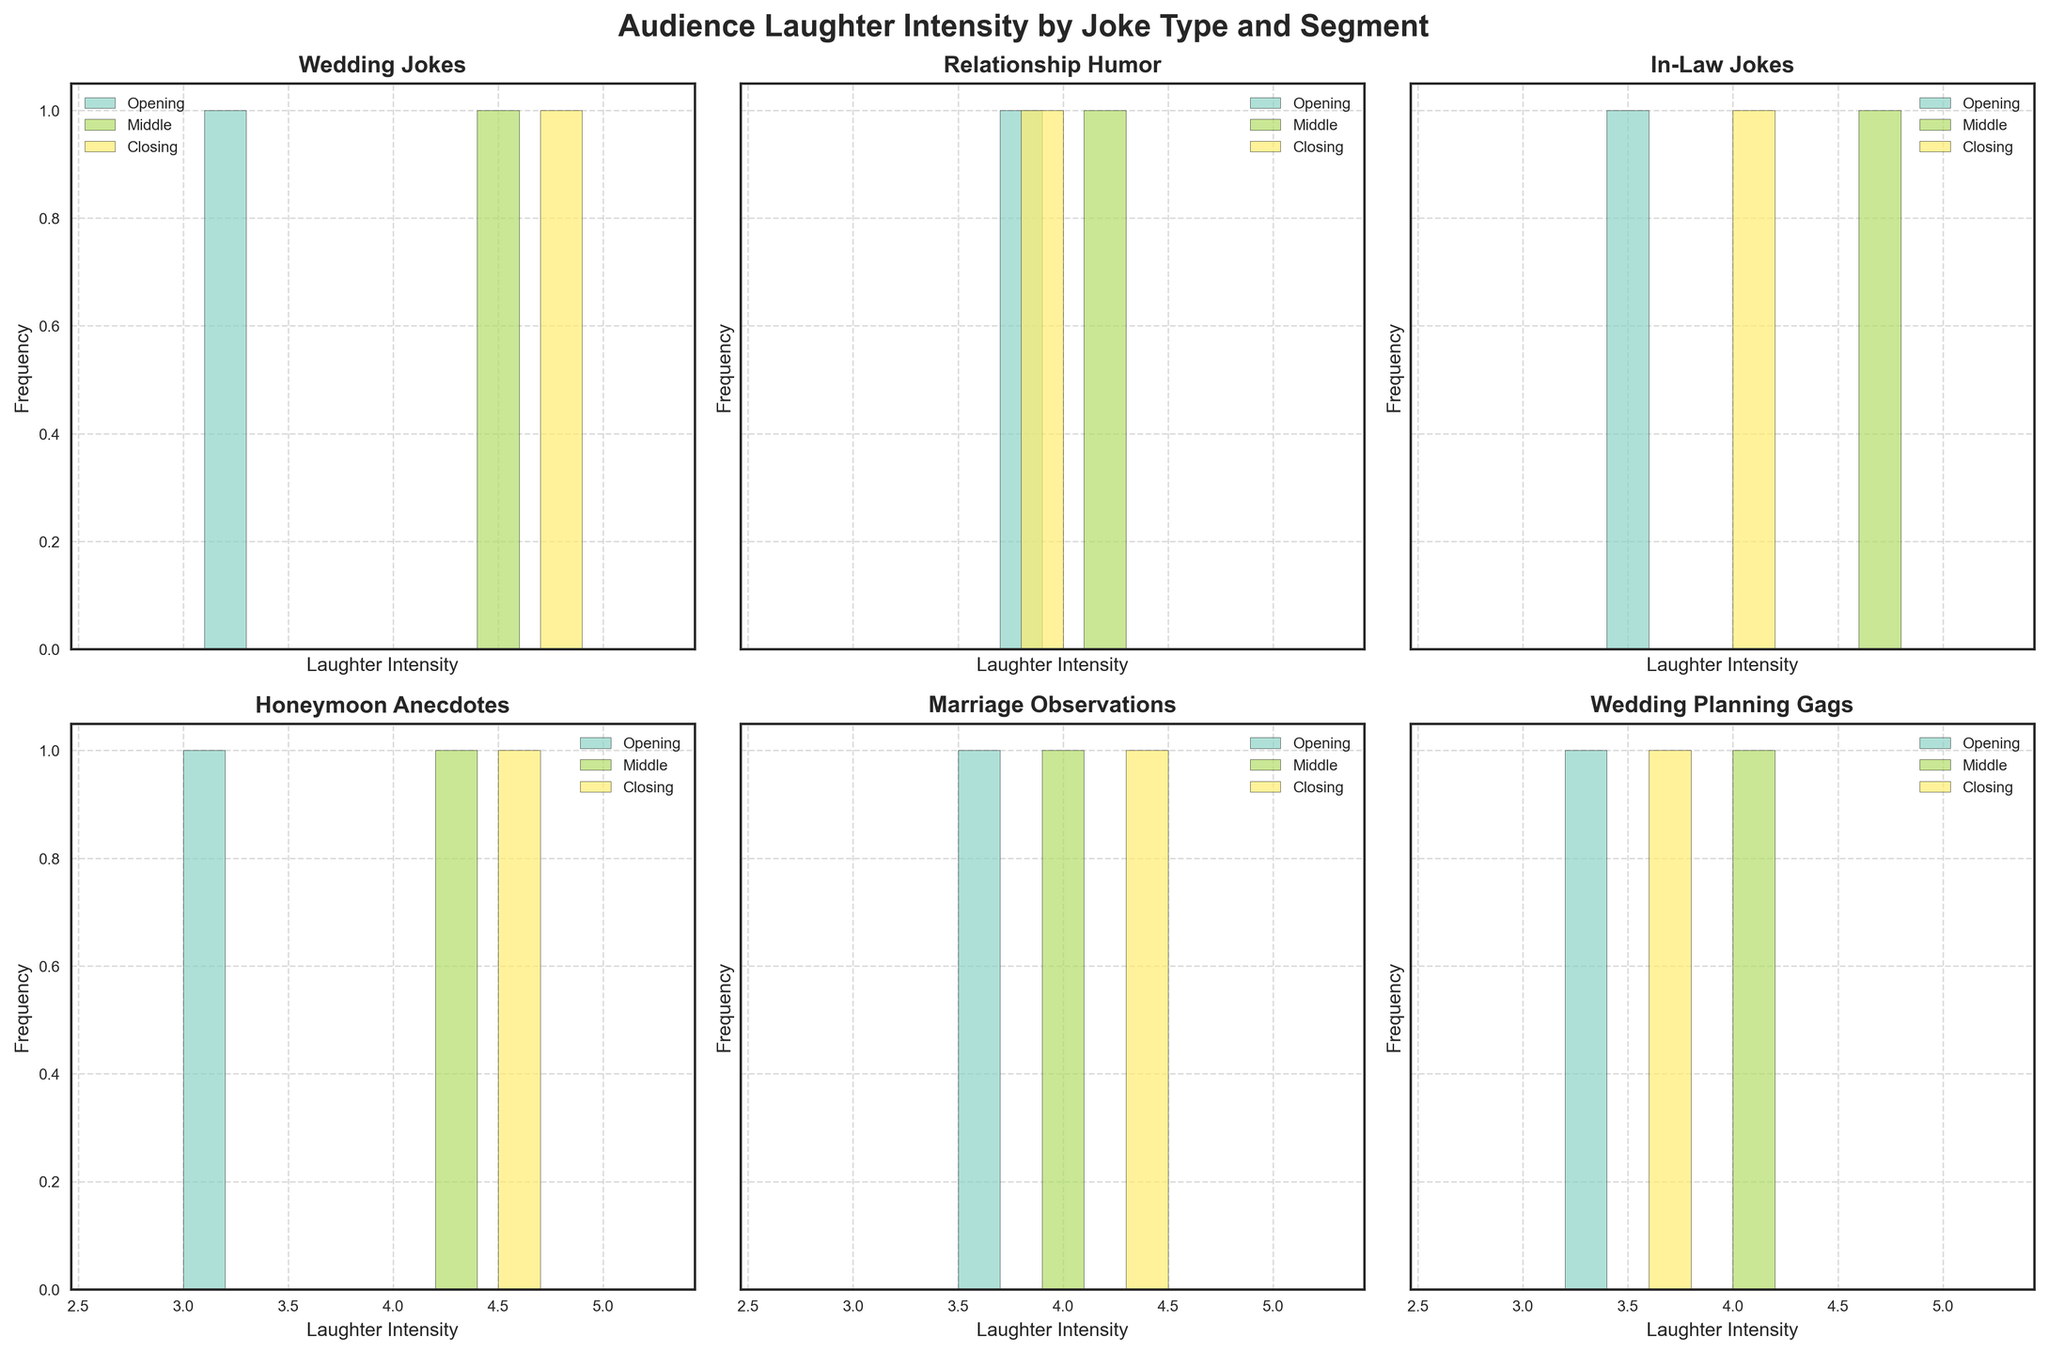Which segment has the highest laughter intensity for the "Wedding Jokes" category? Look at the "Wedding Jokes" category and observe the three segments. The "Closing" segment has the highest laughter intensity at 4.8.
Answer: Closing What's the overall trend in laughter intensity from Opening to Closing for the "Relationship Humor" category? Observe the laughter intensity values for the "Relationship Humor" category from Opening (3.8) to Middle (4.2) to Closing (3.9). The trend is slightly upward from Opening to Middle but then decreases a bit at Closing.
Answer: Increases then decreases Which Joke Type has the lowest laughter intensity in the Opening segment? Compare the Opening segment values across all joke types. "Honeymoon Anecdotes" has the lowest laughter intensity at 3.1 in the Opening segment.
Answer: Honeymoon Anecdotes Between "Marriage Observations" and "Wedding Planning Gags," which one has a better performance in the Middle segment? Compare the Middle segment values for "Marriage Observations" (4.0) and "Wedding Planning Gags" (4.1). "Wedding Planning Gags" has a slightly better performance at 4.1.
Answer: Wedding Planning Gags For the "In-Law Jokes," what is the difference in laughter intensity between the Middle and Closing segments? Look at the laughter intensity for "In-Law Jokes" in the Middle (4.7) and Closing (4.1) segments. The difference is 4.7 - 4.1 = 0.6.
Answer: 0.6 Which joke type is most consistent in laughter intensity across all segments? Compare the variation in laughter intensity for each joke type across all segments. "Marriage Observations" show the least variation (3.6, 4.0, 4.4) compared to others.
Answer: Marriage Observations Rank the joke types based on their Closing segment laughter intensity. List the Closing segment laughter intensities for each joke type and rank them. The order is: Wedding Jokes (4.8), Honeymoon Anecdotes (4.6), Marriage Observations (4.4), Relationship Humor (3.9), Wedding Planning Gags (3.7), In-Law Jokes (4.1).
Answer: Wedding Jokes, Honeymoon Anecdotes, Marriage Observations, In-Law Jokes, Relationship Humor, Wedding Planning Gags What is the average laughter intensity for "Wedding Planning Gags"? Sum the laughter intensities for "Wedding Planning Gags" (3.3, 4.1, 3.7) and divide by the number of segments. The average is (3.3 + 4.1 + 3.7) / 3 = 3.7.
Answer: 3.7 How does the performance of "Honeymoon Anecdotes" in the Middle segment compare to "Relationship Humor" in the Middle segment? Compare the Middle segment values for "Honeymoon Anecdotes" (4.3) and "Relationship Humor" (4.2). "Honeymoon Anecdotes" performs slightly better at 4.3.
Answer: Honeymoon Anecdotes In which joke type does the Closing segment show a marked improvement over the Opening segment? Identify joke types where the Closing segment laughter intensity is much higher than the Opening segment. "Wedding Jokes" show improvement from 3.2 in Opening to 4.8 in Closing.
Answer: Wedding Jokes 